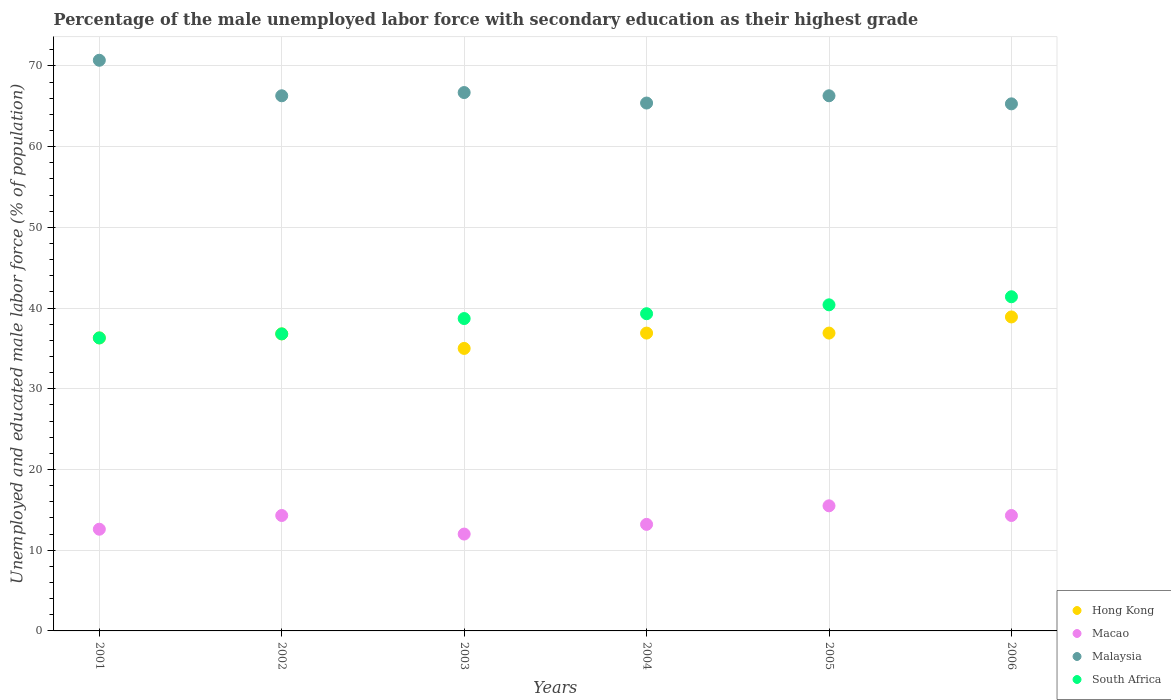Is the number of dotlines equal to the number of legend labels?
Your answer should be compact. Yes. What is the percentage of the unemployed male labor force with secondary education in South Africa in 2006?
Offer a terse response. 41.4. Across all years, what is the maximum percentage of the unemployed male labor force with secondary education in Malaysia?
Give a very brief answer. 70.7. In which year was the percentage of the unemployed male labor force with secondary education in Hong Kong maximum?
Your answer should be compact. 2006. In which year was the percentage of the unemployed male labor force with secondary education in Hong Kong minimum?
Offer a very short reply. 2003. What is the total percentage of the unemployed male labor force with secondary education in Macao in the graph?
Your response must be concise. 81.9. What is the difference between the percentage of the unemployed male labor force with secondary education in Macao in 2002 and that in 2003?
Offer a very short reply. 2.3. What is the difference between the percentage of the unemployed male labor force with secondary education in Hong Kong in 2006 and the percentage of the unemployed male labor force with secondary education in Macao in 2001?
Keep it short and to the point. 26.3. What is the average percentage of the unemployed male labor force with secondary education in Malaysia per year?
Your answer should be compact. 66.78. In the year 2005, what is the difference between the percentage of the unemployed male labor force with secondary education in Malaysia and percentage of the unemployed male labor force with secondary education in Macao?
Your response must be concise. 50.8. In how many years, is the percentage of the unemployed male labor force with secondary education in Macao greater than 68 %?
Provide a short and direct response. 0. What is the ratio of the percentage of the unemployed male labor force with secondary education in Macao in 2005 to that in 2006?
Your answer should be compact. 1.08. Is the percentage of the unemployed male labor force with secondary education in Malaysia in 2001 less than that in 2006?
Ensure brevity in your answer.  No. Is the difference between the percentage of the unemployed male labor force with secondary education in Malaysia in 2003 and 2004 greater than the difference between the percentage of the unemployed male labor force with secondary education in Macao in 2003 and 2004?
Make the answer very short. Yes. What is the difference between the highest and the lowest percentage of the unemployed male labor force with secondary education in Malaysia?
Ensure brevity in your answer.  5.4. In how many years, is the percentage of the unemployed male labor force with secondary education in Malaysia greater than the average percentage of the unemployed male labor force with secondary education in Malaysia taken over all years?
Offer a very short reply. 1. Is it the case that in every year, the sum of the percentage of the unemployed male labor force with secondary education in Macao and percentage of the unemployed male labor force with secondary education in Hong Kong  is greater than the sum of percentage of the unemployed male labor force with secondary education in South Africa and percentage of the unemployed male labor force with secondary education in Malaysia?
Give a very brief answer. Yes. Is it the case that in every year, the sum of the percentage of the unemployed male labor force with secondary education in Macao and percentage of the unemployed male labor force with secondary education in South Africa  is greater than the percentage of the unemployed male labor force with secondary education in Malaysia?
Make the answer very short. No. How many dotlines are there?
Ensure brevity in your answer.  4. What is the difference between two consecutive major ticks on the Y-axis?
Keep it short and to the point. 10. Does the graph contain grids?
Provide a succinct answer. Yes. Where does the legend appear in the graph?
Provide a short and direct response. Bottom right. How are the legend labels stacked?
Give a very brief answer. Vertical. What is the title of the graph?
Offer a very short reply. Percentage of the male unemployed labor force with secondary education as their highest grade. What is the label or title of the X-axis?
Your response must be concise. Years. What is the label or title of the Y-axis?
Offer a terse response. Unemployed and educated male labor force (% of population). What is the Unemployed and educated male labor force (% of population) of Hong Kong in 2001?
Your response must be concise. 36.3. What is the Unemployed and educated male labor force (% of population) in Macao in 2001?
Ensure brevity in your answer.  12.6. What is the Unemployed and educated male labor force (% of population) of Malaysia in 2001?
Make the answer very short. 70.7. What is the Unemployed and educated male labor force (% of population) of South Africa in 2001?
Ensure brevity in your answer.  36.3. What is the Unemployed and educated male labor force (% of population) in Hong Kong in 2002?
Give a very brief answer. 36.8. What is the Unemployed and educated male labor force (% of population) of Macao in 2002?
Your answer should be very brief. 14.3. What is the Unemployed and educated male labor force (% of population) of Malaysia in 2002?
Offer a terse response. 66.3. What is the Unemployed and educated male labor force (% of population) of South Africa in 2002?
Your answer should be very brief. 36.8. What is the Unemployed and educated male labor force (% of population) in Macao in 2003?
Keep it short and to the point. 12. What is the Unemployed and educated male labor force (% of population) of Malaysia in 2003?
Make the answer very short. 66.7. What is the Unemployed and educated male labor force (% of population) of South Africa in 2003?
Your answer should be compact. 38.7. What is the Unemployed and educated male labor force (% of population) of Hong Kong in 2004?
Give a very brief answer. 36.9. What is the Unemployed and educated male labor force (% of population) of Macao in 2004?
Ensure brevity in your answer.  13.2. What is the Unemployed and educated male labor force (% of population) in Malaysia in 2004?
Your answer should be very brief. 65.4. What is the Unemployed and educated male labor force (% of population) in South Africa in 2004?
Make the answer very short. 39.3. What is the Unemployed and educated male labor force (% of population) of Hong Kong in 2005?
Offer a terse response. 36.9. What is the Unemployed and educated male labor force (% of population) of Malaysia in 2005?
Provide a succinct answer. 66.3. What is the Unemployed and educated male labor force (% of population) in South Africa in 2005?
Your response must be concise. 40.4. What is the Unemployed and educated male labor force (% of population) of Hong Kong in 2006?
Make the answer very short. 38.9. What is the Unemployed and educated male labor force (% of population) in Macao in 2006?
Provide a short and direct response. 14.3. What is the Unemployed and educated male labor force (% of population) of Malaysia in 2006?
Keep it short and to the point. 65.3. What is the Unemployed and educated male labor force (% of population) in South Africa in 2006?
Give a very brief answer. 41.4. Across all years, what is the maximum Unemployed and educated male labor force (% of population) in Hong Kong?
Ensure brevity in your answer.  38.9. Across all years, what is the maximum Unemployed and educated male labor force (% of population) of Malaysia?
Your response must be concise. 70.7. Across all years, what is the maximum Unemployed and educated male labor force (% of population) of South Africa?
Offer a very short reply. 41.4. Across all years, what is the minimum Unemployed and educated male labor force (% of population) in Hong Kong?
Keep it short and to the point. 35. Across all years, what is the minimum Unemployed and educated male labor force (% of population) in Macao?
Offer a very short reply. 12. Across all years, what is the minimum Unemployed and educated male labor force (% of population) in Malaysia?
Provide a short and direct response. 65.3. Across all years, what is the minimum Unemployed and educated male labor force (% of population) in South Africa?
Offer a terse response. 36.3. What is the total Unemployed and educated male labor force (% of population) of Hong Kong in the graph?
Provide a short and direct response. 220.8. What is the total Unemployed and educated male labor force (% of population) in Macao in the graph?
Ensure brevity in your answer.  81.9. What is the total Unemployed and educated male labor force (% of population) of Malaysia in the graph?
Your response must be concise. 400.7. What is the total Unemployed and educated male labor force (% of population) in South Africa in the graph?
Your answer should be very brief. 232.9. What is the difference between the Unemployed and educated male labor force (% of population) of Hong Kong in 2001 and that in 2002?
Provide a short and direct response. -0.5. What is the difference between the Unemployed and educated male labor force (% of population) in South Africa in 2001 and that in 2002?
Ensure brevity in your answer.  -0.5. What is the difference between the Unemployed and educated male labor force (% of population) of Hong Kong in 2001 and that in 2003?
Provide a short and direct response. 1.3. What is the difference between the Unemployed and educated male labor force (% of population) in Hong Kong in 2001 and that in 2004?
Keep it short and to the point. -0.6. What is the difference between the Unemployed and educated male labor force (% of population) in Macao in 2001 and that in 2004?
Your response must be concise. -0.6. What is the difference between the Unemployed and educated male labor force (% of population) in Hong Kong in 2001 and that in 2005?
Ensure brevity in your answer.  -0.6. What is the difference between the Unemployed and educated male labor force (% of population) in Malaysia in 2001 and that in 2005?
Your answer should be compact. 4.4. What is the difference between the Unemployed and educated male labor force (% of population) of South Africa in 2001 and that in 2005?
Make the answer very short. -4.1. What is the difference between the Unemployed and educated male labor force (% of population) in Macao in 2001 and that in 2006?
Offer a very short reply. -1.7. What is the difference between the Unemployed and educated male labor force (% of population) in South Africa in 2001 and that in 2006?
Make the answer very short. -5.1. What is the difference between the Unemployed and educated male labor force (% of population) in Hong Kong in 2002 and that in 2003?
Keep it short and to the point. 1.8. What is the difference between the Unemployed and educated male labor force (% of population) in South Africa in 2002 and that in 2004?
Make the answer very short. -2.5. What is the difference between the Unemployed and educated male labor force (% of population) in Hong Kong in 2002 and that in 2005?
Your response must be concise. -0.1. What is the difference between the Unemployed and educated male labor force (% of population) in Macao in 2002 and that in 2005?
Give a very brief answer. -1.2. What is the difference between the Unemployed and educated male labor force (% of population) in Macao in 2002 and that in 2006?
Offer a terse response. 0. What is the difference between the Unemployed and educated male labor force (% of population) in Macao in 2003 and that in 2004?
Ensure brevity in your answer.  -1.2. What is the difference between the Unemployed and educated male labor force (% of population) in Malaysia in 2003 and that in 2004?
Make the answer very short. 1.3. What is the difference between the Unemployed and educated male labor force (% of population) in Hong Kong in 2003 and that in 2005?
Your answer should be very brief. -1.9. What is the difference between the Unemployed and educated male labor force (% of population) of Macao in 2003 and that in 2005?
Offer a terse response. -3.5. What is the difference between the Unemployed and educated male labor force (% of population) in Hong Kong in 2003 and that in 2006?
Your answer should be compact. -3.9. What is the difference between the Unemployed and educated male labor force (% of population) in Malaysia in 2003 and that in 2006?
Provide a succinct answer. 1.4. What is the difference between the Unemployed and educated male labor force (% of population) of Hong Kong in 2004 and that in 2006?
Ensure brevity in your answer.  -2. What is the difference between the Unemployed and educated male labor force (% of population) of Macao in 2004 and that in 2006?
Ensure brevity in your answer.  -1.1. What is the difference between the Unemployed and educated male labor force (% of population) in Malaysia in 2004 and that in 2006?
Make the answer very short. 0.1. What is the difference between the Unemployed and educated male labor force (% of population) in South Africa in 2004 and that in 2006?
Offer a very short reply. -2.1. What is the difference between the Unemployed and educated male labor force (% of population) of Hong Kong in 2005 and that in 2006?
Offer a very short reply. -2. What is the difference between the Unemployed and educated male labor force (% of population) in Malaysia in 2005 and that in 2006?
Provide a succinct answer. 1. What is the difference between the Unemployed and educated male labor force (% of population) in Hong Kong in 2001 and the Unemployed and educated male labor force (% of population) in Macao in 2002?
Offer a terse response. 22. What is the difference between the Unemployed and educated male labor force (% of population) in Macao in 2001 and the Unemployed and educated male labor force (% of population) in Malaysia in 2002?
Offer a very short reply. -53.7. What is the difference between the Unemployed and educated male labor force (% of population) in Macao in 2001 and the Unemployed and educated male labor force (% of population) in South Africa in 2002?
Your answer should be very brief. -24.2. What is the difference between the Unemployed and educated male labor force (% of population) in Malaysia in 2001 and the Unemployed and educated male labor force (% of population) in South Africa in 2002?
Ensure brevity in your answer.  33.9. What is the difference between the Unemployed and educated male labor force (% of population) in Hong Kong in 2001 and the Unemployed and educated male labor force (% of population) in Macao in 2003?
Keep it short and to the point. 24.3. What is the difference between the Unemployed and educated male labor force (% of population) of Hong Kong in 2001 and the Unemployed and educated male labor force (% of population) of Malaysia in 2003?
Your answer should be compact. -30.4. What is the difference between the Unemployed and educated male labor force (% of population) of Macao in 2001 and the Unemployed and educated male labor force (% of population) of Malaysia in 2003?
Ensure brevity in your answer.  -54.1. What is the difference between the Unemployed and educated male labor force (% of population) of Macao in 2001 and the Unemployed and educated male labor force (% of population) of South Africa in 2003?
Make the answer very short. -26.1. What is the difference between the Unemployed and educated male labor force (% of population) in Hong Kong in 2001 and the Unemployed and educated male labor force (% of population) in Macao in 2004?
Your answer should be compact. 23.1. What is the difference between the Unemployed and educated male labor force (% of population) in Hong Kong in 2001 and the Unemployed and educated male labor force (% of population) in Malaysia in 2004?
Ensure brevity in your answer.  -29.1. What is the difference between the Unemployed and educated male labor force (% of population) in Macao in 2001 and the Unemployed and educated male labor force (% of population) in Malaysia in 2004?
Provide a succinct answer. -52.8. What is the difference between the Unemployed and educated male labor force (% of population) in Macao in 2001 and the Unemployed and educated male labor force (% of population) in South Africa in 2004?
Ensure brevity in your answer.  -26.7. What is the difference between the Unemployed and educated male labor force (% of population) in Malaysia in 2001 and the Unemployed and educated male labor force (% of population) in South Africa in 2004?
Provide a succinct answer. 31.4. What is the difference between the Unemployed and educated male labor force (% of population) in Hong Kong in 2001 and the Unemployed and educated male labor force (% of population) in Macao in 2005?
Your answer should be compact. 20.8. What is the difference between the Unemployed and educated male labor force (% of population) in Hong Kong in 2001 and the Unemployed and educated male labor force (% of population) in Malaysia in 2005?
Offer a terse response. -30. What is the difference between the Unemployed and educated male labor force (% of population) of Hong Kong in 2001 and the Unemployed and educated male labor force (% of population) of South Africa in 2005?
Keep it short and to the point. -4.1. What is the difference between the Unemployed and educated male labor force (% of population) of Macao in 2001 and the Unemployed and educated male labor force (% of population) of Malaysia in 2005?
Provide a succinct answer. -53.7. What is the difference between the Unemployed and educated male labor force (% of population) in Macao in 2001 and the Unemployed and educated male labor force (% of population) in South Africa in 2005?
Provide a short and direct response. -27.8. What is the difference between the Unemployed and educated male labor force (% of population) in Malaysia in 2001 and the Unemployed and educated male labor force (% of population) in South Africa in 2005?
Provide a succinct answer. 30.3. What is the difference between the Unemployed and educated male labor force (% of population) in Macao in 2001 and the Unemployed and educated male labor force (% of population) in Malaysia in 2006?
Provide a succinct answer. -52.7. What is the difference between the Unemployed and educated male labor force (% of population) in Macao in 2001 and the Unemployed and educated male labor force (% of population) in South Africa in 2006?
Offer a very short reply. -28.8. What is the difference between the Unemployed and educated male labor force (% of population) of Malaysia in 2001 and the Unemployed and educated male labor force (% of population) of South Africa in 2006?
Offer a terse response. 29.3. What is the difference between the Unemployed and educated male labor force (% of population) of Hong Kong in 2002 and the Unemployed and educated male labor force (% of population) of Macao in 2003?
Your answer should be compact. 24.8. What is the difference between the Unemployed and educated male labor force (% of population) in Hong Kong in 2002 and the Unemployed and educated male labor force (% of population) in Malaysia in 2003?
Provide a succinct answer. -29.9. What is the difference between the Unemployed and educated male labor force (% of population) of Hong Kong in 2002 and the Unemployed and educated male labor force (% of population) of South Africa in 2003?
Your response must be concise. -1.9. What is the difference between the Unemployed and educated male labor force (% of population) of Macao in 2002 and the Unemployed and educated male labor force (% of population) of Malaysia in 2003?
Offer a terse response. -52.4. What is the difference between the Unemployed and educated male labor force (% of population) of Macao in 2002 and the Unemployed and educated male labor force (% of population) of South Africa in 2003?
Keep it short and to the point. -24.4. What is the difference between the Unemployed and educated male labor force (% of population) of Malaysia in 2002 and the Unemployed and educated male labor force (% of population) of South Africa in 2003?
Make the answer very short. 27.6. What is the difference between the Unemployed and educated male labor force (% of population) in Hong Kong in 2002 and the Unemployed and educated male labor force (% of population) in Macao in 2004?
Give a very brief answer. 23.6. What is the difference between the Unemployed and educated male labor force (% of population) in Hong Kong in 2002 and the Unemployed and educated male labor force (% of population) in Malaysia in 2004?
Your answer should be compact. -28.6. What is the difference between the Unemployed and educated male labor force (% of population) of Macao in 2002 and the Unemployed and educated male labor force (% of population) of Malaysia in 2004?
Give a very brief answer. -51.1. What is the difference between the Unemployed and educated male labor force (% of population) in Macao in 2002 and the Unemployed and educated male labor force (% of population) in South Africa in 2004?
Your response must be concise. -25. What is the difference between the Unemployed and educated male labor force (% of population) in Hong Kong in 2002 and the Unemployed and educated male labor force (% of population) in Macao in 2005?
Your response must be concise. 21.3. What is the difference between the Unemployed and educated male labor force (% of population) in Hong Kong in 2002 and the Unemployed and educated male labor force (% of population) in Malaysia in 2005?
Your answer should be very brief. -29.5. What is the difference between the Unemployed and educated male labor force (% of population) in Hong Kong in 2002 and the Unemployed and educated male labor force (% of population) in South Africa in 2005?
Your answer should be very brief. -3.6. What is the difference between the Unemployed and educated male labor force (% of population) of Macao in 2002 and the Unemployed and educated male labor force (% of population) of Malaysia in 2005?
Offer a very short reply. -52. What is the difference between the Unemployed and educated male labor force (% of population) of Macao in 2002 and the Unemployed and educated male labor force (% of population) of South Africa in 2005?
Make the answer very short. -26.1. What is the difference between the Unemployed and educated male labor force (% of population) of Malaysia in 2002 and the Unemployed and educated male labor force (% of population) of South Africa in 2005?
Your answer should be compact. 25.9. What is the difference between the Unemployed and educated male labor force (% of population) in Hong Kong in 2002 and the Unemployed and educated male labor force (% of population) in Malaysia in 2006?
Provide a short and direct response. -28.5. What is the difference between the Unemployed and educated male labor force (% of population) in Macao in 2002 and the Unemployed and educated male labor force (% of population) in Malaysia in 2006?
Provide a short and direct response. -51. What is the difference between the Unemployed and educated male labor force (% of population) in Macao in 2002 and the Unemployed and educated male labor force (% of population) in South Africa in 2006?
Give a very brief answer. -27.1. What is the difference between the Unemployed and educated male labor force (% of population) of Malaysia in 2002 and the Unemployed and educated male labor force (% of population) of South Africa in 2006?
Your response must be concise. 24.9. What is the difference between the Unemployed and educated male labor force (% of population) in Hong Kong in 2003 and the Unemployed and educated male labor force (% of population) in Macao in 2004?
Offer a very short reply. 21.8. What is the difference between the Unemployed and educated male labor force (% of population) of Hong Kong in 2003 and the Unemployed and educated male labor force (% of population) of Malaysia in 2004?
Give a very brief answer. -30.4. What is the difference between the Unemployed and educated male labor force (% of population) in Hong Kong in 2003 and the Unemployed and educated male labor force (% of population) in South Africa in 2004?
Give a very brief answer. -4.3. What is the difference between the Unemployed and educated male labor force (% of population) in Macao in 2003 and the Unemployed and educated male labor force (% of population) in Malaysia in 2004?
Offer a terse response. -53.4. What is the difference between the Unemployed and educated male labor force (% of population) of Macao in 2003 and the Unemployed and educated male labor force (% of population) of South Africa in 2004?
Provide a succinct answer. -27.3. What is the difference between the Unemployed and educated male labor force (% of population) in Malaysia in 2003 and the Unemployed and educated male labor force (% of population) in South Africa in 2004?
Offer a terse response. 27.4. What is the difference between the Unemployed and educated male labor force (% of population) in Hong Kong in 2003 and the Unemployed and educated male labor force (% of population) in Macao in 2005?
Your answer should be very brief. 19.5. What is the difference between the Unemployed and educated male labor force (% of population) in Hong Kong in 2003 and the Unemployed and educated male labor force (% of population) in Malaysia in 2005?
Keep it short and to the point. -31.3. What is the difference between the Unemployed and educated male labor force (% of population) in Hong Kong in 2003 and the Unemployed and educated male labor force (% of population) in South Africa in 2005?
Your response must be concise. -5.4. What is the difference between the Unemployed and educated male labor force (% of population) in Macao in 2003 and the Unemployed and educated male labor force (% of population) in Malaysia in 2005?
Provide a short and direct response. -54.3. What is the difference between the Unemployed and educated male labor force (% of population) in Macao in 2003 and the Unemployed and educated male labor force (% of population) in South Africa in 2005?
Your answer should be compact. -28.4. What is the difference between the Unemployed and educated male labor force (% of population) in Malaysia in 2003 and the Unemployed and educated male labor force (% of population) in South Africa in 2005?
Offer a very short reply. 26.3. What is the difference between the Unemployed and educated male labor force (% of population) of Hong Kong in 2003 and the Unemployed and educated male labor force (% of population) of Macao in 2006?
Your answer should be compact. 20.7. What is the difference between the Unemployed and educated male labor force (% of population) in Hong Kong in 2003 and the Unemployed and educated male labor force (% of population) in Malaysia in 2006?
Give a very brief answer. -30.3. What is the difference between the Unemployed and educated male labor force (% of population) of Hong Kong in 2003 and the Unemployed and educated male labor force (% of population) of South Africa in 2006?
Provide a succinct answer. -6.4. What is the difference between the Unemployed and educated male labor force (% of population) in Macao in 2003 and the Unemployed and educated male labor force (% of population) in Malaysia in 2006?
Keep it short and to the point. -53.3. What is the difference between the Unemployed and educated male labor force (% of population) of Macao in 2003 and the Unemployed and educated male labor force (% of population) of South Africa in 2006?
Keep it short and to the point. -29.4. What is the difference between the Unemployed and educated male labor force (% of population) in Malaysia in 2003 and the Unemployed and educated male labor force (% of population) in South Africa in 2006?
Make the answer very short. 25.3. What is the difference between the Unemployed and educated male labor force (% of population) in Hong Kong in 2004 and the Unemployed and educated male labor force (% of population) in Macao in 2005?
Give a very brief answer. 21.4. What is the difference between the Unemployed and educated male labor force (% of population) of Hong Kong in 2004 and the Unemployed and educated male labor force (% of population) of Malaysia in 2005?
Your answer should be very brief. -29.4. What is the difference between the Unemployed and educated male labor force (% of population) of Macao in 2004 and the Unemployed and educated male labor force (% of population) of Malaysia in 2005?
Provide a succinct answer. -53.1. What is the difference between the Unemployed and educated male labor force (% of population) of Macao in 2004 and the Unemployed and educated male labor force (% of population) of South Africa in 2005?
Offer a terse response. -27.2. What is the difference between the Unemployed and educated male labor force (% of population) of Hong Kong in 2004 and the Unemployed and educated male labor force (% of population) of Macao in 2006?
Your answer should be very brief. 22.6. What is the difference between the Unemployed and educated male labor force (% of population) in Hong Kong in 2004 and the Unemployed and educated male labor force (% of population) in Malaysia in 2006?
Offer a terse response. -28.4. What is the difference between the Unemployed and educated male labor force (% of population) in Hong Kong in 2004 and the Unemployed and educated male labor force (% of population) in South Africa in 2006?
Ensure brevity in your answer.  -4.5. What is the difference between the Unemployed and educated male labor force (% of population) in Macao in 2004 and the Unemployed and educated male labor force (% of population) in Malaysia in 2006?
Your response must be concise. -52.1. What is the difference between the Unemployed and educated male labor force (% of population) of Macao in 2004 and the Unemployed and educated male labor force (% of population) of South Africa in 2006?
Your answer should be very brief. -28.2. What is the difference between the Unemployed and educated male labor force (% of population) of Malaysia in 2004 and the Unemployed and educated male labor force (% of population) of South Africa in 2006?
Give a very brief answer. 24. What is the difference between the Unemployed and educated male labor force (% of population) in Hong Kong in 2005 and the Unemployed and educated male labor force (% of population) in Macao in 2006?
Keep it short and to the point. 22.6. What is the difference between the Unemployed and educated male labor force (% of population) of Hong Kong in 2005 and the Unemployed and educated male labor force (% of population) of Malaysia in 2006?
Keep it short and to the point. -28.4. What is the difference between the Unemployed and educated male labor force (% of population) in Macao in 2005 and the Unemployed and educated male labor force (% of population) in Malaysia in 2006?
Offer a terse response. -49.8. What is the difference between the Unemployed and educated male labor force (% of population) of Macao in 2005 and the Unemployed and educated male labor force (% of population) of South Africa in 2006?
Offer a terse response. -25.9. What is the difference between the Unemployed and educated male labor force (% of population) in Malaysia in 2005 and the Unemployed and educated male labor force (% of population) in South Africa in 2006?
Provide a succinct answer. 24.9. What is the average Unemployed and educated male labor force (% of population) in Hong Kong per year?
Make the answer very short. 36.8. What is the average Unemployed and educated male labor force (% of population) in Macao per year?
Give a very brief answer. 13.65. What is the average Unemployed and educated male labor force (% of population) in Malaysia per year?
Provide a succinct answer. 66.78. What is the average Unemployed and educated male labor force (% of population) of South Africa per year?
Make the answer very short. 38.82. In the year 2001, what is the difference between the Unemployed and educated male labor force (% of population) in Hong Kong and Unemployed and educated male labor force (% of population) in Macao?
Offer a very short reply. 23.7. In the year 2001, what is the difference between the Unemployed and educated male labor force (% of population) in Hong Kong and Unemployed and educated male labor force (% of population) in Malaysia?
Your answer should be very brief. -34.4. In the year 2001, what is the difference between the Unemployed and educated male labor force (% of population) of Hong Kong and Unemployed and educated male labor force (% of population) of South Africa?
Ensure brevity in your answer.  0. In the year 2001, what is the difference between the Unemployed and educated male labor force (% of population) of Macao and Unemployed and educated male labor force (% of population) of Malaysia?
Your answer should be compact. -58.1. In the year 2001, what is the difference between the Unemployed and educated male labor force (% of population) of Macao and Unemployed and educated male labor force (% of population) of South Africa?
Your answer should be very brief. -23.7. In the year 2001, what is the difference between the Unemployed and educated male labor force (% of population) of Malaysia and Unemployed and educated male labor force (% of population) of South Africa?
Provide a succinct answer. 34.4. In the year 2002, what is the difference between the Unemployed and educated male labor force (% of population) of Hong Kong and Unemployed and educated male labor force (% of population) of Macao?
Provide a succinct answer. 22.5. In the year 2002, what is the difference between the Unemployed and educated male labor force (% of population) of Hong Kong and Unemployed and educated male labor force (% of population) of Malaysia?
Your answer should be very brief. -29.5. In the year 2002, what is the difference between the Unemployed and educated male labor force (% of population) of Macao and Unemployed and educated male labor force (% of population) of Malaysia?
Provide a succinct answer. -52. In the year 2002, what is the difference between the Unemployed and educated male labor force (% of population) in Macao and Unemployed and educated male labor force (% of population) in South Africa?
Provide a succinct answer. -22.5. In the year 2002, what is the difference between the Unemployed and educated male labor force (% of population) of Malaysia and Unemployed and educated male labor force (% of population) of South Africa?
Make the answer very short. 29.5. In the year 2003, what is the difference between the Unemployed and educated male labor force (% of population) of Hong Kong and Unemployed and educated male labor force (% of population) of Malaysia?
Make the answer very short. -31.7. In the year 2003, what is the difference between the Unemployed and educated male labor force (% of population) of Macao and Unemployed and educated male labor force (% of population) of Malaysia?
Ensure brevity in your answer.  -54.7. In the year 2003, what is the difference between the Unemployed and educated male labor force (% of population) of Macao and Unemployed and educated male labor force (% of population) of South Africa?
Your answer should be compact. -26.7. In the year 2003, what is the difference between the Unemployed and educated male labor force (% of population) in Malaysia and Unemployed and educated male labor force (% of population) in South Africa?
Provide a short and direct response. 28. In the year 2004, what is the difference between the Unemployed and educated male labor force (% of population) of Hong Kong and Unemployed and educated male labor force (% of population) of Macao?
Your answer should be very brief. 23.7. In the year 2004, what is the difference between the Unemployed and educated male labor force (% of population) of Hong Kong and Unemployed and educated male labor force (% of population) of Malaysia?
Provide a succinct answer. -28.5. In the year 2004, what is the difference between the Unemployed and educated male labor force (% of population) in Macao and Unemployed and educated male labor force (% of population) in Malaysia?
Ensure brevity in your answer.  -52.2. In the year 2004, what is the difference between the Unemployed and educated male labor force (% of population) of Macao and Unemployed and educated male labor force (% of population) of South Africa?
Provide a short and direct response. -26.1. In the year 2004, what is the difference between the Unemployed and educated male labor force (% of population) of Malaysia and Unemployed and educated male labor force (% of population) of South Africa?
Provide a succinct answer. 26.1. In the year 2005, what is the difference between the Unemployed and educated male labor force (% of population) in Hong Kong and Unemployed and educated male labor force (% of population) in Macao?
Your answer should be very brief. 21.4. In the year 2005, what is the difference between the Unemployed and educated male labor force (% of population) of Hong Kong and Unemployed and educated male labor force (% of population) of Malaysia?
Provide a succinct answer. -29.4. In the year 2005, what is the difference between the Unemployed and educated male labor force (% of population) in Hong Kong and Unemployed and educated male labor force (% of population) in South Africa?
Keep it short and to the point. -3.5. In the year 2005, what is the difference between the Unemployed and educated male labor force (% of population) of Macao and Unemployed and educated male labor force (% of population) of Malaysia?
Keep it short and to the point. -50.8. In the year 2005, what is the difference between the Unemployed and educated male labor force (% of population) of Macao and Unemployed and educated male labor force (% of population) of South Africa?
Keep it short and to the point. -24.9. In the year 2005, what is the difference between the Unemployed and educated male labor force (% of population) of Malaysia and Unemployed and educated male labor force (% of population) of South Africa?
Make the answer very short. 25.9. In the year 2006, what is the difference between the Unemployed and educated male labor force (% of population) in Hong Kong and Unemployed and educated male labor force (% of population) in Macao?
Your answer should be very brief. 24.6. In the year 2006, what is the difference between the Unemployed and educated male labor force (% of population) of Hong Kong and Unemployed and educated male labor force (% of population) of Malaysia?
Provide a short and direct response. -26.4. In the year 2006, what is the difference between the Unemployed and educated male labor force (% of population) in Macao and Unemployed and educated male labor force (% of population) in Malaysia?
Provide a short and direct response. -51. In the year 2006, what is the difference between the Unemployed and educated male labor force (% of population) in Macao and Unemployed and educated male labor force (% of population) in South Africa?
Your answer should be compact. -27.1. In the year 2006, what is the difference between the Unemployed and educated male labor force (% of population) of Malaysia and Unemployed and educated male labor force (% of population) of South Africa?
Keep it short and to the point. 23.9. What is the ratio of the Unemployed and educated male labor force (% of population) in Hong Kong in 2001 to that in 2002?
Ensure brevity in your answer.  0.99. What is the ratio of the Unemployed and educated male labor force (% of population) in Macao in 2001 to that in 2002?
Your answer should be very brief. 0.88. What is the ratio of the Unemployed and educated male labor force (% of population) in Malaysia in 2001 to that in 2002?
Provide a short and direct response. 1.07. What is the ratio of the Unemployed and educated male labor force (% of population) of South Africa in 2001 to that in 2002?
Your answer should be compact. 0.99. What is the ratio of the Unemployed and educated male labor force (% of population) in Hong Kong in 2001 to that in 2003?
Ensure brevity in your answer.  1.04. What is the ratio of the Unemployed and educated male labor force (% of population) of Malaysia in 2001 to that in 2003?
Offer a terse response. 1.06. What is the ratio of the Unemployed and educated male labor force (% of population) of South Africa in 2001 to that in 2003?
Your response must be concise. 0.94. What is the ratio of the Unemployed and educated male labor force (% of population) in Hong Kong in 2001 to that in 2004?
Make the answer very short. 0.98. What is the ratio of the Unemployed and educated male labor force (% of population) of Macao in 2001 to that in 2004?
Ensure brevity in your answer.  0.95. What is the ratio of the Unemployed and educated male labor force (% of population) of Malaysia in 2001 to that in 2004?
Make the answer very short. 1.08. What is the ratio of the Unemployed and educated male labor force (% of population) of South Africa in 2001 to that in 2004?
Provide a short and direct response. 0.92. What is the ratio of the Unemployed and educated male labor force (% of population) of Hong Kong in 2001 to that in 2005?
Provide a short and direct response. 0.98. What is the ratio of the Unemployed and educated male labor force (% of population) in Macao in 2001 to that in 2005?
Your response must be concise. 0.81. What is the ratio of the Unemployed and educated male labor force (% of population) of Malaysia in 2001 to that in 2005?
Provide a short and direct response. 1.07. What is the ratio of the Unemployed and educated male labor force (% of population) of South Africa in 2001 to that in 2005?
Provide a succinct answer. 0.9. What is the ratio of the Unemployed and educated male labor force (% of population) in Hong Kong in 2001 to that in 2006?
Your response must be concise. 0.93. What is the ratio of the Unemployed and educated male labor force (% of population) of Macao in 2001 to that in 2006?
Ensure brevity in your answer.  0.88. What is the ratio of the Unemployed and educated male labor force (% of population) of Malaysia in 2001 to that in 2006?
Offer a very short reply. 1.08. What is the ratio of the Unemployed and educated male labor force (% of population) of South Africa in 2001 to that in 2006?
Offer a very short reply. 0.88. What is the ratio of the Unemployed and educated male labor force (% of population) in Hong Kong in 2002 to that in 2003?
Provide a short and direct response. 1.05. What is the ratio of the Unemployed and educated male labor force (% of population) in Macao in 2002 to that in 2003?
Make the answer very short. 1.19. What is the ratio of the Unemployed and educated male labor force (% of population) of Malaysia in 2002 to that in 2003?
Ensure brevity in your answer.  0.99. What is the ratio of the Unemployed and educated male labor force (% of population) of South Africa in 2002 to that in 2003?
Provide a succinct answer. 0.95. What is the ratio of the Unemployed and educated male labor force (% of population) of Macao in 2002 to that in 2004?
Your answer should be compact. 1.08. What is the ratio of the Unemployed and educated male labor force (% of population) of Malaysia in 2002 to that in 2004?
Your answer should be compact. 1.01. What is the ratio of the Unemployed and educated male labor force (% of population) of South Africa in 2002 to that in 2004?
Your answer should be very brief. 0.94. What is the ratio of the Unemployed and educated male labor force (% of population) in Macao in 2002 to that in 2005?
Offer a terse response. 0.92. What is the ratio of the Unemployed and educated male labor force (% of population) in South Africa in 2002 to that in 2005?
Ensure brevity in your answer.  0.91. What is the ratio of the Unemployed and educated male labor force (% of population) of Hong Kong in 2002 to that in 2006?
Ensure brevity in your answer.  0.95. What is the ratio of the Unemployed and educated male labor force (% of population) in Malaysia in 2002 to that in 2006?
Offer a terse response. 1.02. What is the ratio of the Unemployed and educated male labor force (% of population) in Hong Kong in 2003 to that in 2004?
Offer a terse response. 0.95. What is the ratio of the Unemployed and educated male labor force (% of population) of Macao in 2003 to that in 2004?
Give a very brief answer. 0.91. What is the ratio of the Unemployed and educated male labor force (% of population) of Malaysia in 2003 to that in 2004?
Make the answer very short. 1.02. What is the ratio of the Unemployed and educated male labor force (% of population) in South Africa in 2003 to that in 2004?
Make the answer very short. 0.98. What is the ratio of the Unemployed and educated male labor force (% of population) of Hong Kong in 2003 to that in 2005?
Your answer should be compact. 0.95. What is the ratio of the Unemployed and educated male labor force (% of population) of Macao in 2003 to that in 2005?
Give a very brief answer. 0.77. What is the ratio of the Unemployed and educated male labor force (% of population) of Malaysia in 2003 to that in 2005?
Make the answer very short. 1.01. What is the ratio of the Unemployed and educated male labor force (% of population) in South Africa in 2003 to that in 2005?
Provide a short and direct response. 0.96. What is the ratio of the Unemployed and educated male labor force (% of population) of Hong Kong in 2003 to that in 2006?
Your answer should be very brief. 0.9. What is the ratio of the Unemployed and educated male labor force (% of population) in Macao in 2003 to that in 2006?
Offer a very short reply. 0.84. What is the ratio of the Unemployed and educated male labor force (% of population) in Malaysia in 2003 to that in 2006?
Your response must be concise. 1.02. What is the ratio of the Unemployed and educated male labor force (% of population) of South Africa in 2003 to that in 2006?
Make the answer very short. 0.93. What is the ratio of the Unemployed and educated male labor force (% of population) in Macao in 2004 to that in 2005?
Give a very brief answer. 0.85. What is the ratio of the Unemployed and educated male labor force (% of population) of Malaysia in 2004 to that in 2005?
Provide a succinct answer. 0.99. What is the ratio of the Unemployed and educated male labor force (% of population) in South Africa in 2004 to that in 2005?
Offer a terse response. 0.97. What is the ratio of the Unemployed and educated male labor force (% of population) of Hong Kong in 2004 to that in 2006?
Ensure brevity in your answer.  0.95. What is the ratio of the Unemployed and educated male labor force (% of population) in Macao in 2004 to that in 2006?
Provide a succinct answer. 0.92. What is the ratio of the Unemployed and educated male labor force (% of population) of Malaysia in 2004 to that in 2006?
Give a very brief answer. 1. What is the ratio of the Unemployed and educated male labor force (% of population) in South Africa in 2004 to that in 2006?
Provide a short and direct response. 0.95. What is the ratio of the Unemployed and educated male labor force (% of population) of Hong Kong in 2005 to that in 2006?
Keep it short and to the point. 0.95. What is the ratio of the Unemployed and educated male labor force (% of population) of Macao in 2005 to that in 2006?
Give a very brief answer. 1.08. What is the ratio of the Unemployed and educated male labor force (% of population) in Malaysia in 2005 to that in 2006?
Provide a short and direct response. 1.02. What is the ratio of the Unemployed and educated male labor force (% of population) in South Africa in 2005 to that in 2006?
Your answer should be compact. 0.98. What is the difference between the highest and the second highest Unemployed and educated male labor force (% of population) of Hong Kong?
Your answer should be very brief. 2. What is the difference between the highest and the second highest Unemployed and educated male labor force (% of population) in Macao?
Your response must be concise. 1.2. What is the difference between the highest and the second highest Unemployed and educated male labor force (% of population) of Malaysia?
Your response must be concise. 4. What is the difference between the highest and the lowest Unemployed and educated male labor force (% of population) of Malaysia?
Ensure brevity in your answer.  5.4. 